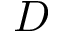Convert formula to latex. <formula><loc_0><loc_0><loc_500><loc_500>D</formula> 